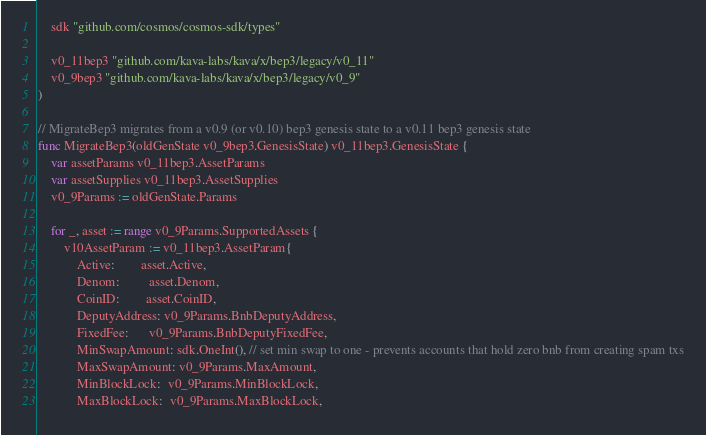Convert code to text. <code><loc_0><loc_0><loc_500><loc_500><_Go_>	sdk "github.com/cosmos/cosmos-sdk/types"

	v0_11bep3 "github.com/kava-labs/kava/x/bep3/legacy/v0_11"
	v0_9bep3 "github.com/kava-labs/kava/x/bep3/legacy/v0_9"
)

// MigrateBep3 migrates from a v0.9 (or v0.10) bep3 genesis state to a v0.11 bep3 genesis state
func MigrateBep3(oldGenState v0_9bep3.GenesisState) v0_11bep3.GenesisState {
	var assetParams v0_11bep3.AssetParams
	var assetSupplies v0_11bep3.AssetSupplies
	v0_9Params := oldGenState.Params

	for _, asset := range v0_9Params.SupportedAssets {
		v10AssetParam := v0_11bep3.AssetParam{
			Active:        asset.Active,
			Denom:         asset.Denom,
			CoinID:        asset.CoinID,
			DeputyAddress: v0_9Params.BnbDeputyAddress,
			FixedFee:      v0_9Params.BnbDeputyFixedFee,
			MinSwapAmount: sdk.OneInt(), // set min swap to one - prevents accounts that hold zero bnb from creating spam txs
			MaxSwapAmount: v0_9Params.MaxAmount,
			MinBlockLock:  v0_9Params.MinBlockLock,
			MaxBlockLock:  v0_9Params.MaxBlockLock,</code> 